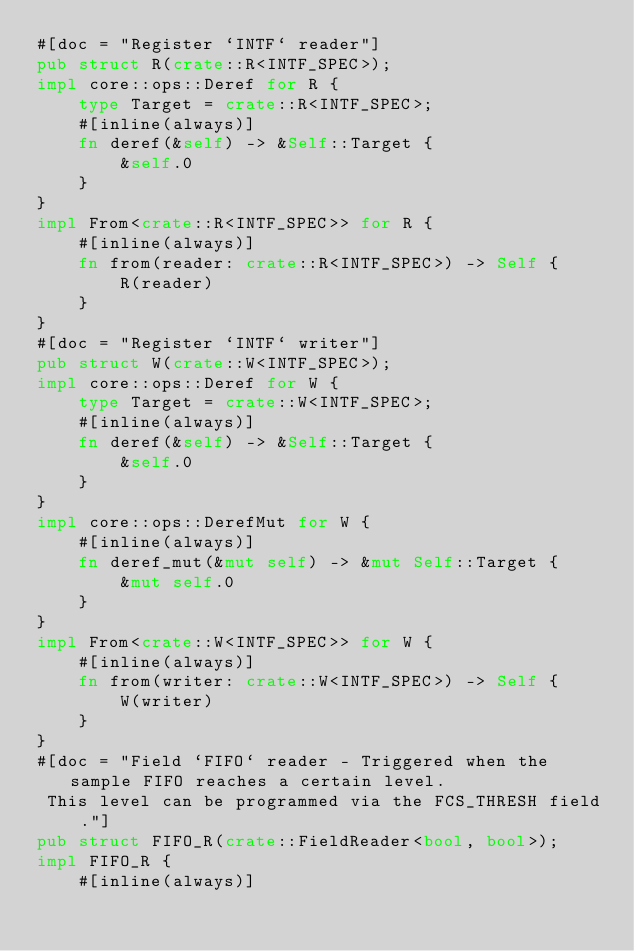Convert code to text. <code><loc_0><loc_0><loc_500><loc_500><_Rust_>#[doc = "Register `INTF` reader"]
pub struct R(crate::R<INTF_SPEC>);
impl core::ops::Deref for R {
    type Target = crate::R<INTF_SPEC>;
    #[inline(always)]
    fn deref(&self) -> &Self::Target {
        &self.0
    }
}
impl From<crate::R<INTF_SPEC>> for R {
    #[inline(always)]
    fn from(reader: crate::R<INTF_SPEC>) -> Self {
        R(reader)
    }
}
#[doc = "Register `INTF` writer"]
pub struct W(crate::W<INTF_SPEC>);
impl core::ops::Deref for W {
    type Target = crate::W<INTF_SPEC>;
    #[inline(always)]
    fn deref(&self) -> &Self::Target {
        &self.0
    }
}
impl core::ops::DerefMut for W {
    #[inline(always)]
    fn deref_mut(&mut self) -> &mut Self::Target {
        &mut self.0
    }
}
impl From<crate::W<INTF_SPEC>> for W {
    #[inline(always)]
    fn from(writer: crate::W<INTF_SPEC>) -> Self {
        W(writer)
    }
}
#[doc = "Field `FIFO` reader - Triggered when the sample FIFO reaches a certain level.  
 This level can be programmed via the FCS_THRESH field."]
pub struct FIFO_R(crate::FieldReader<bool, bool>);
impl FIFO_R {
    #[inline(always)]</code> 